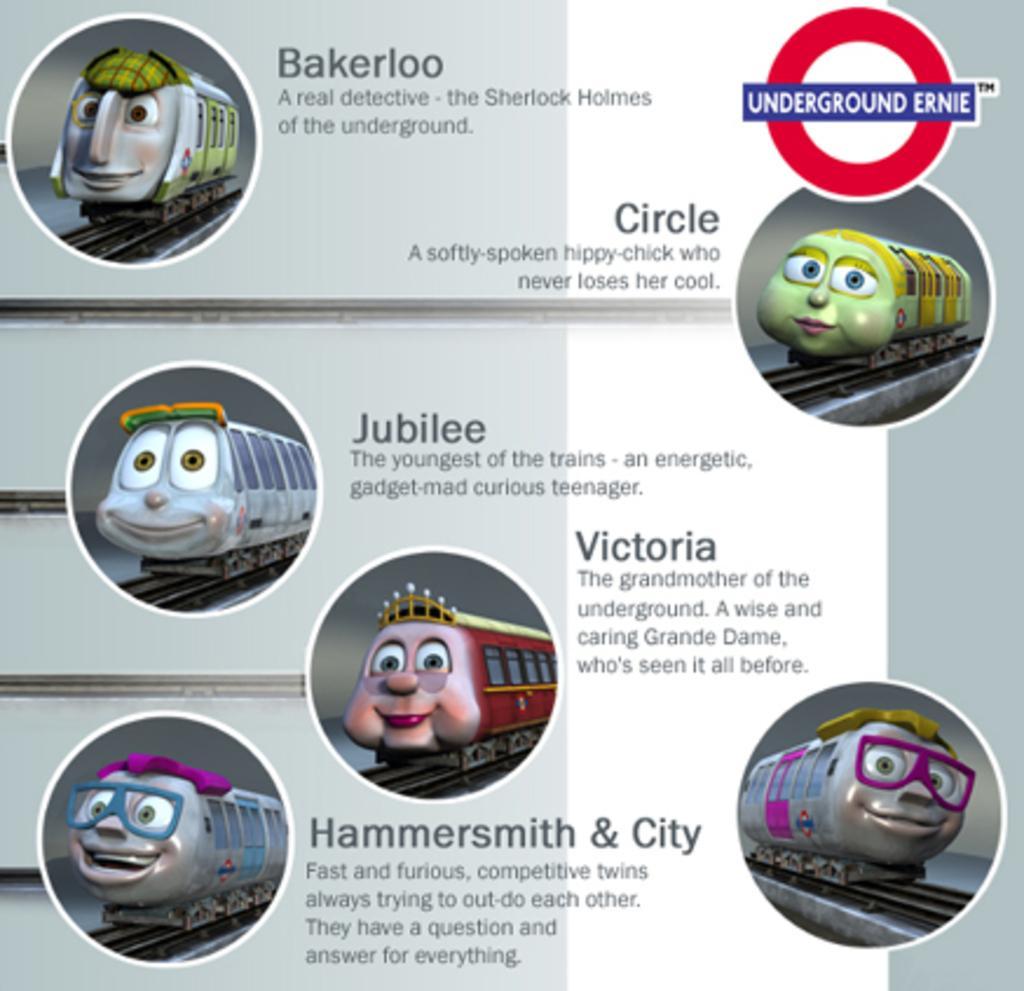Could you give a brief overview of what you see in this image? There is a poster in which, there are cartoon images and texts. These cartoon images are having trains. The background of this poster is gray in color. 